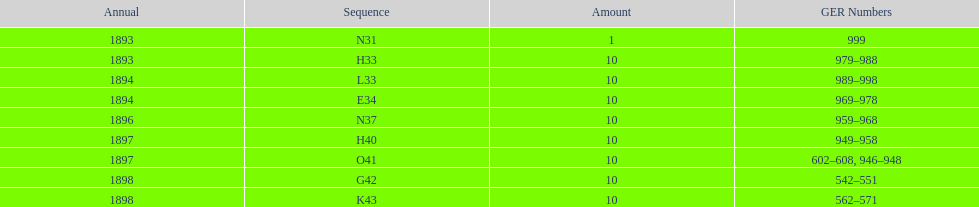Was the quantity higher in 1894 or 1893? 1894. 